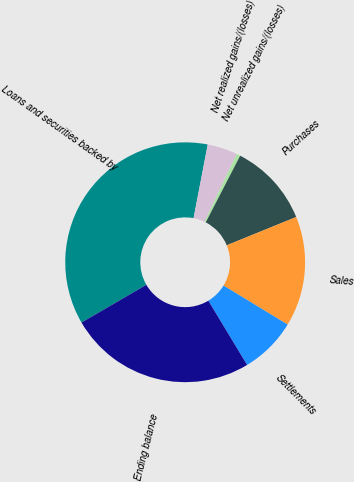<chart> <loc_0><loc_0><loc_500><loc_500><pie_chart><fcel>Loans and securities backed by<fcel>Net realized gains/(losses)<fcel>Net unrealized gains/(losses)<fcel>Purchases<fcel>Sales<fcel>Settlements<fcel>Ending balance<nl><fcel>36.4%<fcel>4.08%<fcel>0.49%<fcel>11.26%<fcel>14.85%<fcel>7.67%<fcel>25.25%<nl></chart> 